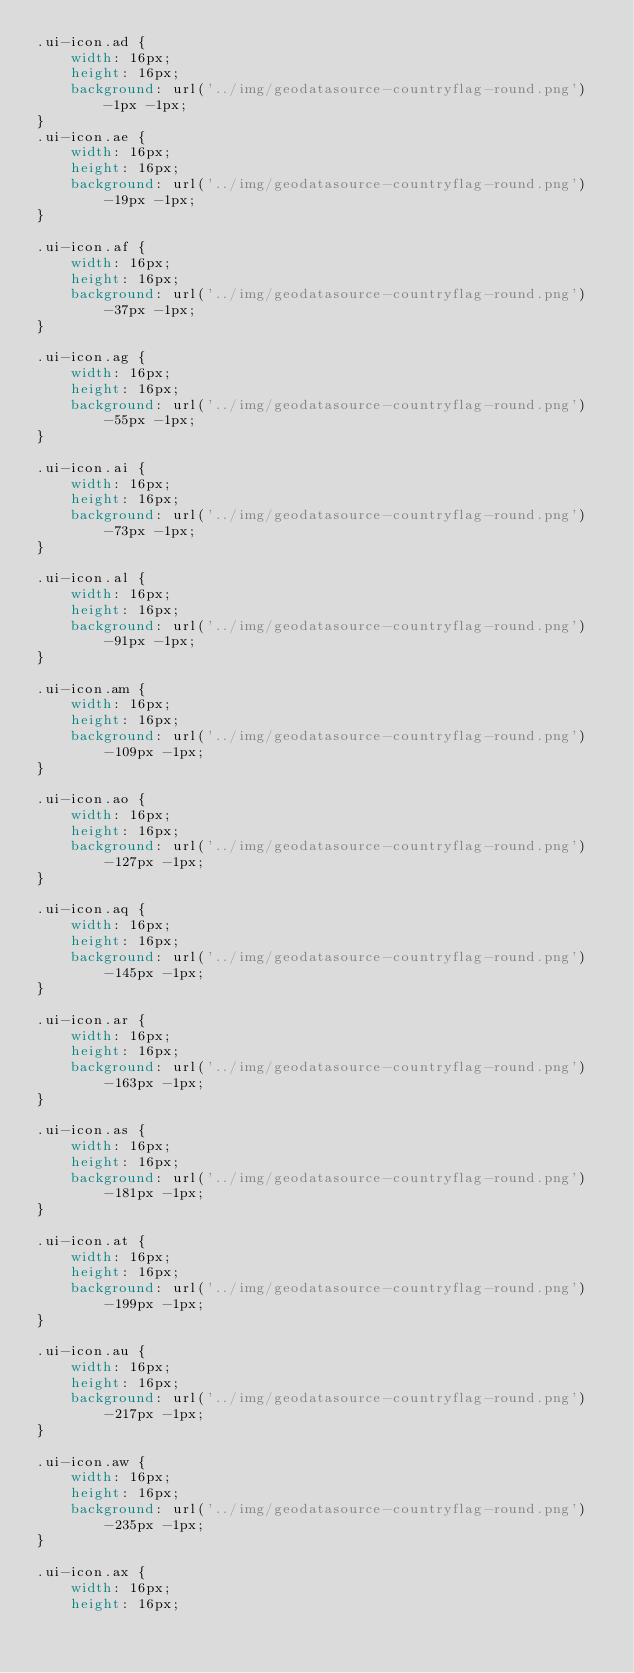<code> <loc_0><loc_0><loc_500><loc_500><_CSS_>.ui-icon.ad {
    width: 16px;
    height: 16px;
    background: url('../img/geodatasource-countryflag-round.png') -1px -1px;
}
.ui-icon.ae {
    width: 16px;
    height: 16px;
    background: url('../img/geodatasource-countryflag-round.png') -19px -1px;
}

.ui-icon.af {
    width: 16px;
    height: 16px;
    background: url('../img/geodatasource-countryflag-round.png') -37px -1px;
}

.ui-icon.ag {
    width: 16px;
    height: 16px;
    background: url('../img/geodatasource-countryflag-round.png') -55px -1px;
}

.ui-icon.ai {
    width: 16px;
    height: 16px;
    background: url('../img/geodatasource-countryflag-round.png') -73px -1px;
}

.ui-icon.al {
    width: 16px;
    height: 16px;
    background: url('../img/geodatasource-countryflag-round.png') -91px -1px;
}

.ui-icon.am {
    width: 16px;
    height: 16px;
    background: url('../img/geodatasource-countryflag-round.png') -109px -1px;
}

.ui-icon.ao {
    width: 16px;
    height: 16px;
    background: url('../img/geodatasource-countryflag-round.png') -127px -1px;
}

.ui-icon.aq {
    width: 16px;
    height: 16px;
    background: url('../img/geodatasource-countryflag-round.png') -145px -1px;
}

.ui-icon.ar {
    width: 16px;
    height: 16px;
    background: url('../img/geodatasource-countryflag-round.png') -163px -1px;
}

.ui-icon.as {
    width: 16px;
    height: 16px;
    background: url('../img/geodatasource-countryflag-round.png') -181px -1px;
}

.ui-icon.at {
    width: 16px;
    height: 16px;
    background: url('../img/geodatasource-countryflag-round.png') -199px -1px;
}

.ui-icon.au {
    width: 16px;
    height: 16px;
    background: url('../img/geodatasource-countryflag-round.png') -217px -1px;
}

.ui-icon.aw {
    width: 16px;
    height: 16px;
    background: url('../img/geodatasource-countryflag-round.png') -235px -1px;
}

.ui-icon.ax {
    width: 16px;
    height: 16px;</code> 